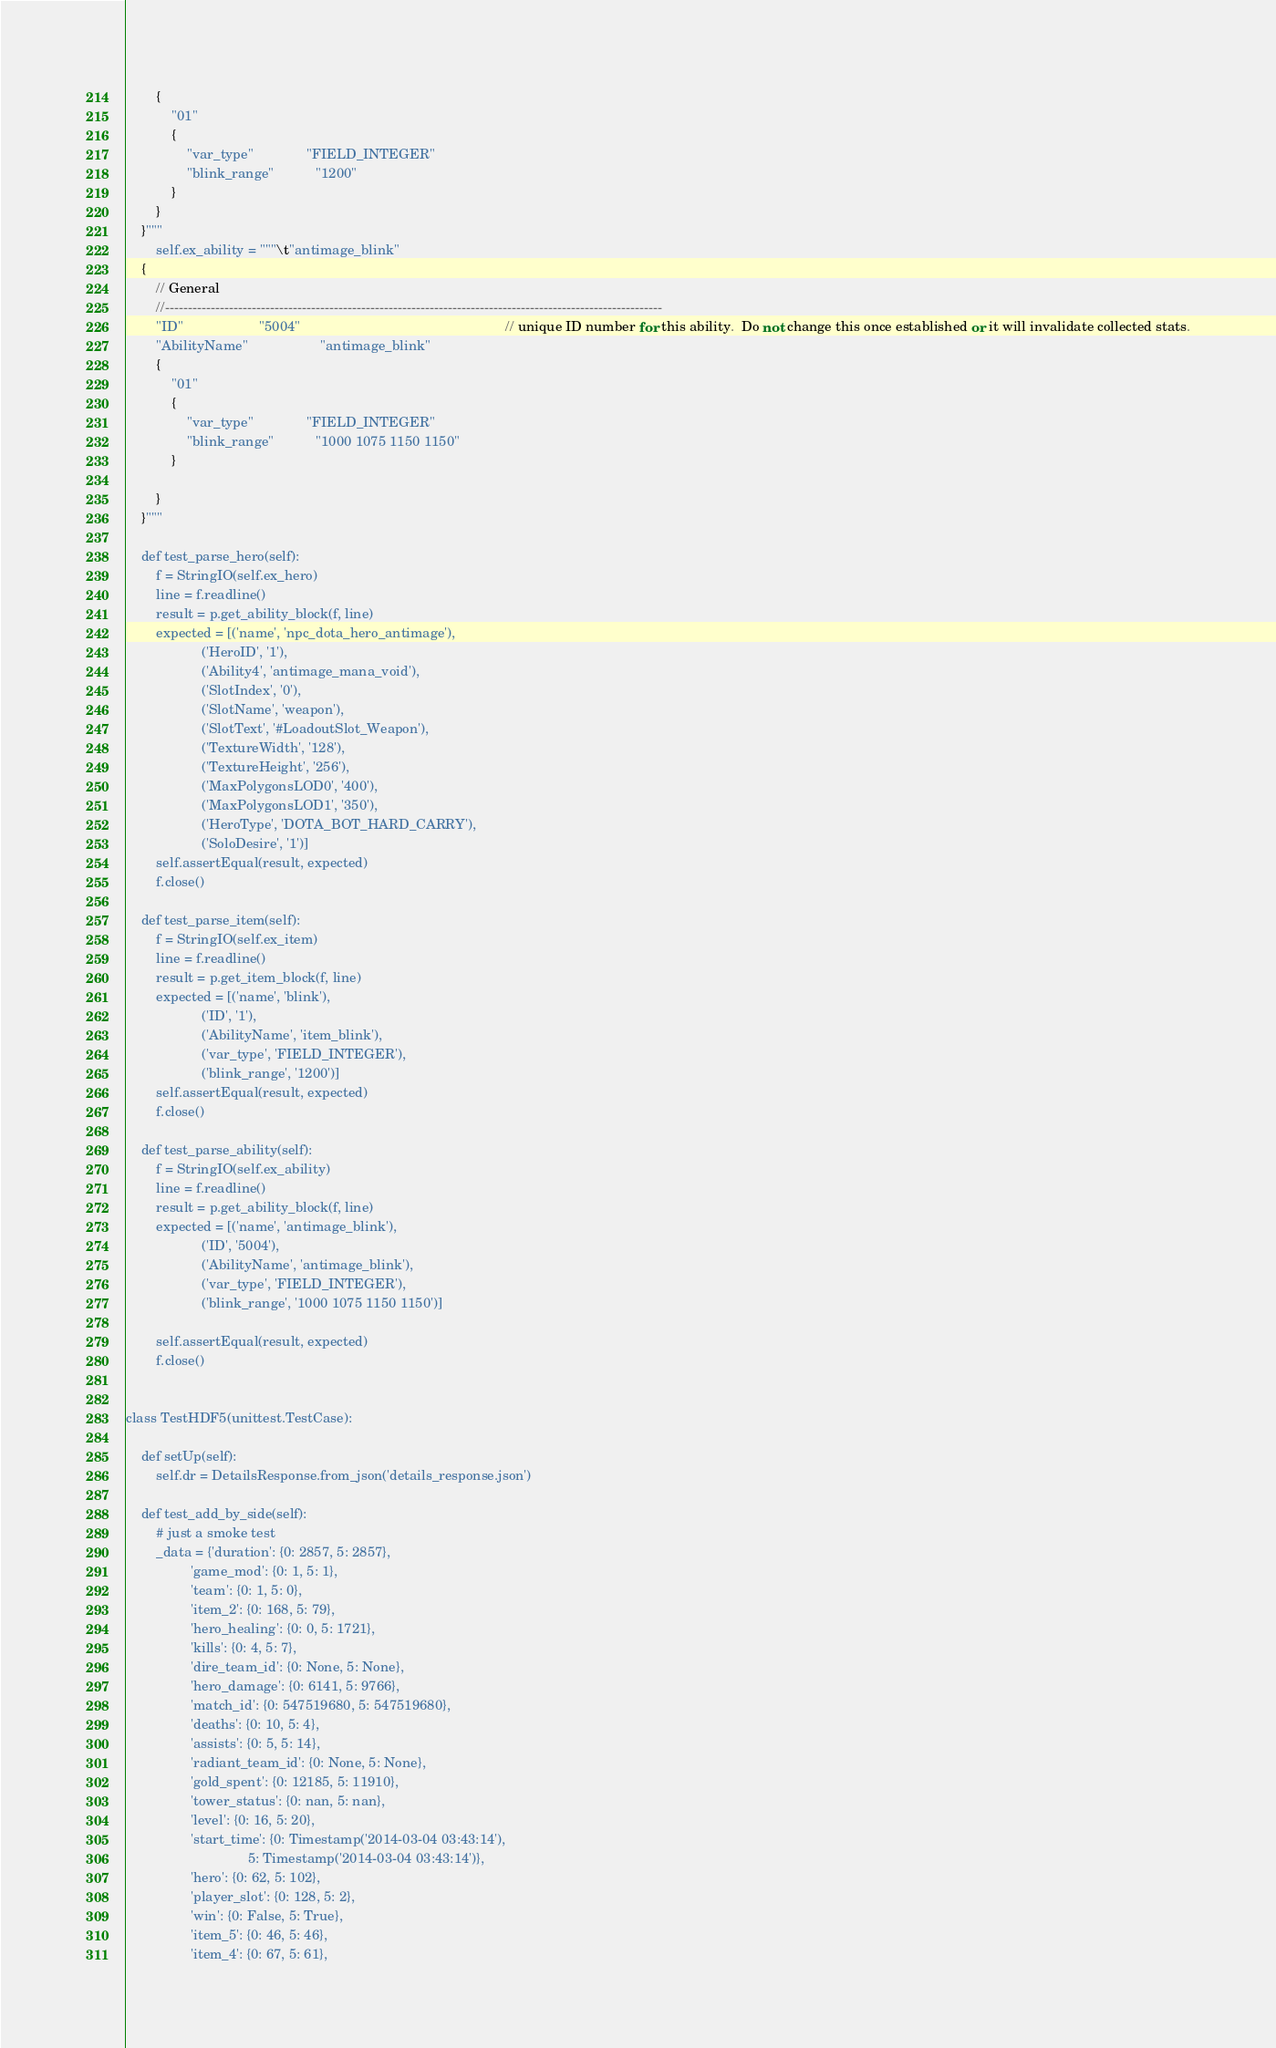Convert code to text. <code><loc_0><loc_0><loc_500><loc_500><_Python_>        {
            "01"
            {
                "var_type"              "FIELD_INTEGER"
                "blink_range"           "1200"
            }
        }
    }"""
        self.ex_ability = """\t"antimage_blink"
    {
        // General
        //-------------------------------------------------------------------------------------------------------------
        "ID"                    "5004"                                                      // unique ID number for this ability.  Do not change this once established or it will invalidate collected stats.
        "AbilityName"                   "antimage_blink"
        {
            "01"
            {
                "var_type"              "FIELD_INTEGER"
                "blink_range"           "1000 1075 1150 1150"
            }

        }
    }"""

    def test_parse_hero(self):
        f = StringIO(self.ex_hero)
        line = f.readline()
        result = p.get_ability_block(f, line)
        expected = [('name', 'npc_dota_hero_antimage'),
                    ('HeroID', '1'),
                    ('Ability4', 'antimage_mana_void'),
                    ('SlotIndex', '0'),
                    ('SlotName', 'weapon'),
                    ('SlotText', '#LoadoutSlot_Weapon'),
                    ('TextureWidth', '128'),
                    ('TextureHeight', '256'),
                    ('MaxPolygonsLOD0', '400'),
                    ('MaxPolygonsLOD1', '350'),
                    ('HeroType', 'DOTA_BOT_HARD_CARRY'),
                    ('SoloDesire', '1')]
        self.assertEqual(result, expected)
        f.close()

    def test_parse_item(self):
        f = StringIO(self.ex_item)
        line = f.readline()
        result = p.get_item_block(f, line)
        expected = [('name', 'blink'),
                    ('ID', '1'),
                    ('AbilityName', 'item_blink'),
                    ('var_type', 'FIELD_INTEGER'),
                    ('blink_range', '1200')]
        self.assertEqual(result, expected)
        f.close()

    def test_parse_ability(self):
        f = StringIO(self.ex_ability)
        line = f.readline()
        result = p.get_ability_block(f, line)
        expected = [('name', 'antimage_blink'),
                    ('ID', '5004'),
                    ('AbilityName', 'antimage_blink'),
                    ('var_type', 'FIELD_INTEGER'),
                    ('blink_range', '1000 1075 1150 1150')]

        self.assertEqual(result, expected)
        f.close()


class TestHDF5(unittest.TestCase):

    def setUp(self):
        self.dr = DetailsResponse.from_json('details_response.json')

    def test_add_by_side(self):
        # just a smoke test
        _data = {'duration': {0: 2857, 5: 2857},
                 'game_mod': {0: 1, 5: 1},
                 'team': {0: 1, 5: 0},
                 'item_2': {0: 168, 5: 79},
                 'hero_healing': {0: 0, 5: 1721},
                 'kills': {0: 4, 5: 7},
                 'dire_team_id': {0: None, 5: None},
                 'hero_damage': {0: 6141, 5: 9766},
                 'match_id': {0: 547519680, 5: 547519680},
                 'deaths': {0: 10, 5: 4},
                 'assists': {0: 5, 5: 14},
                 'radiant_team_id': {0: None, 5: None},
                 'gold_spent': {0: 12185, 5: 11910},
                 'tower_status': {0: nan, 5: nan},
                 'level': {0: 16, 5: 20},
                 'start_time': {0: Timestamp('2014-03-04 03:43:14'),
                                5: Timestamp('2014-03-04 03:43:14')},
                 'hero': {0: 62, 5: 102},
                 'player_slot': {0: 128, 5: 2},
                 'win': {0: False, 5: True},
                 'item_5': {0: 46, 5: 46},
                 'item_4': {0: 67, 5: 61},</code> 